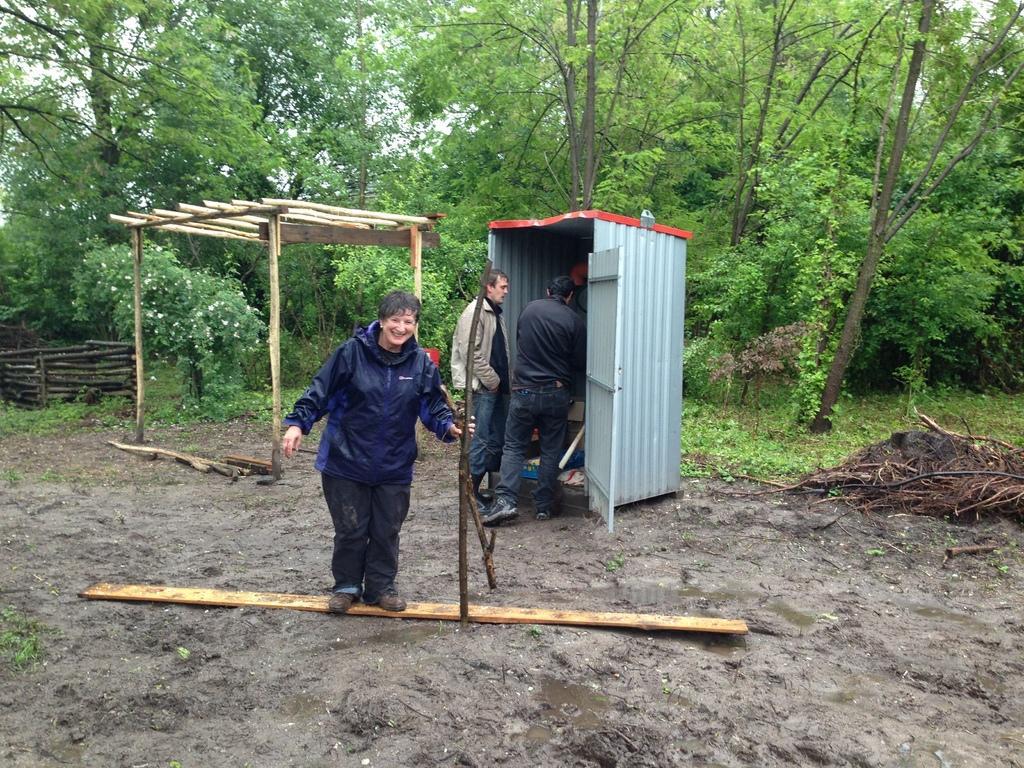How would you summarize this image in a sentence or two? In this image I can see few people are standing and I can see one of them is wearing blue colour rain coat. I can also see smile on her face. In the background I can see number of trees and on ground I can see grass, wood and few other things. 